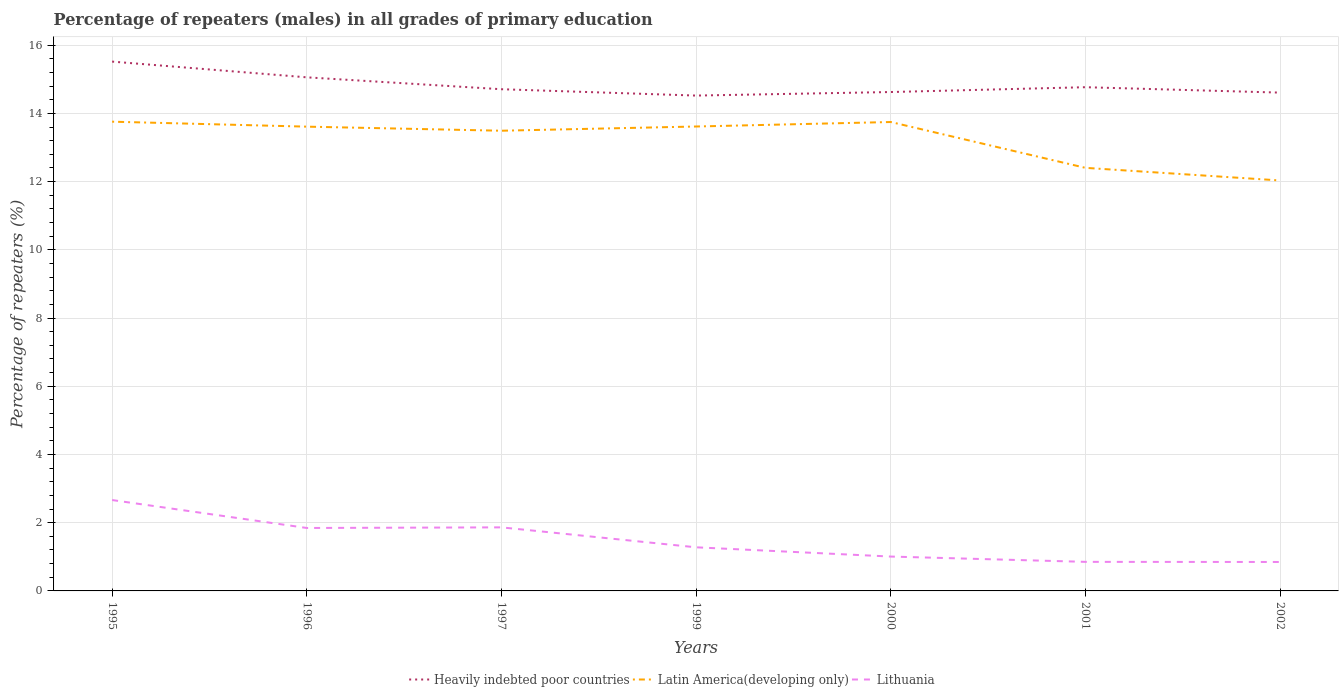How many different coloured lines are there?
Ensure brevity in your answer.  3. Across all years, what is the maximum percentage of repeaters (males) in Lithuania?
Provide a succinct answer. 0.85. In which year was the percentage of repeaters (males) in Latin America(developing only) maximum?
Make the answer very short. 2002. What is the total percentage of repeaters (males) in Latin America(developing only) in the graph?
Provide a short and direct response. 1.21. What is the difference between the highest and the second highest percentage of repeaters (males) in Lithuania?
Your response must be concise. 1.82. Is the percentage of repeaters (males) in Heavily indebted poor countries strictly greater than the percentage of repeaters (males) in Lithuania over the years?
Provide a succinct answer. No. How many years are there in the graph?
Your response must be concise. 7. What is the difference between two consecutive major ticks on the Y-axis?
Keep it short and to the point. 2. Are the values on the major ticks of Y-axis written in scientific E-notation?
Provide a short and direct response. No. Does the graph contain grids?
Offer a very short reply. Yes. How many legend labels are there?
Your response must be concise. 3. How are the legend labels stacked?
Provide a short and direct response. Horizontal. What is the title of the graph?
Offer a terse response. Percentage of repeaters (males) in all grades of primary education. Does "Sri Lanka" appear as one of the legend labels in the graph?
Your answer should be compact. No. What is the label or title of the Y-axis?
Make the answer very short. Percentage of repeaters (%). What is the Percentage of repeaters (%) of Heavily indebted poor countries in 1995?
Your answer should be very brief. 15.52. What is the Percentage of repeaters (%) of Latin America(developing only) in 1995?
Your answer should be compact. 13.76. What is the Percentage of repeaters (%) in Lithuania in 1995?
Ensure brevity in your answer.  2.66. What is the Percentage of repeaters (%) of Heavily indebted poor countries in 1996?
Offer a terse response. 15.06. What is the Percentage of repeaters (%) in Latin America(developing only) in 1996?
Keep it short and to the point. 13.61. What is the Percentage of repeaters (%) of Lithuania in 1996?
Your answer should be compact. 1.85. What is the Percentage of repeaters (%) of Heavily indebted poor countries in 1997?
Your answer should be compact. 14.71. What is the Percentage of repeaters (%) of Latin America(developing only) in 1997?
Offer a terse response. 13.49. What is the Percentage of repeaters (%) in Lithuania in 1997?
Keep it short and to the point. 1.86. What is the Percentage of repeaters (%) of Heavily indebted poor countries in 1999?
Provide a succinct answer. 14.52. What is the Percentage of repeaters (%) in Latin America(developing only) in 1999?
Offer a very short reply. 13.62. What is the Percentage of repeaters (%) in Lithuania in 1999?
Provide a short and direct response. 1.28. What is the Percentage of repeaters (%) in Heavily indebted poor countries in 2000?
Your response must be concise. 14.63. What is the Percentage of repeaters (%) in Latin America(developing only) in 2000?
Offer a terse response. 13.75. What is the Percentage of repeaters (%) of Lithuania in 2000?
Your response must be concise. 1.01. What is the Percentage of repeaters (%) of Heavily indebted poor countries in 2001?
Your answer should be compact. 14.77. What is the Percentage of repeaters (%) of Latin America(developing only) in 2001?
Ensure brevity in your answer.  12.4. What is the Percentage of repeaters (%) in Lithuania in 2001?
Provide a short and direct response. 0.85. What is the Percentage of repeaters (%) of Heavily indebted poor countries in 2002?
Offer a terse response. 14.61. What is the Percentage of repeaters (%) in Latin America(developing only) in 2002?
Provide a succinct answer. 12.03. What is the Percentage of repeaters (%) in Lithuania in 2002?
Provide a short and direct response. 0.85. Across all years, what is the maximum Percentage of repeaters (%) of Heavily indebted poor countries?
Offer a very short reply. 15.52. Across all years, what is the maximum Percentage of repeaters (%) of Latin America(developing only)?
Your answer should be compact. 13.76. Across all years, what is the maximum Percentage of repeaters (%) in Lithuania?
Your response must be concise. 2.66. Across all years, what is the minimum Percentage of repeaters (%) in Heavily indebted poor countries?
Give a very brief answer. 14.52. Across all years, what is the minimum Percentage of repeaters (%) in Latin America(developing only)?
Your answer should be compact. 12.03. Across all years, what is the minimum Percentage of repeaters (%) in Lithuania?
Make the answer very short. 0.85. What is the total Percentage of repeaters (%) in Heavily indebted poor countries in the graph?
Make the answer very short. 103.81. What is the total Percentage of repeaters (%) in Latin America(developing only) in the graph?
Make the answer very short. 92.66. What is the total Percentage of repeaters (%) in Lithuania in the graph?
Provide a succinct answer. 10.36. What is the difference between the Percentage of repeaters (%) in Heavily indebted poor countries in 1995 and that in 1996?
Provide a short and direct response. 0.46. What is the difference between the Percentage of repeaters (%) of Latin America(developing only) in 1995 and that in 1996?
Make the answer very short. 0.15. What is the difference between the Percentage of repeaters (%) in Lithuania in 1995 and that in 1996?
Make the answer very short. 0.82. What is the difference between the Percentage of repeaters (%) of Heavily indebted poor countries in 1995 and that in 1997?
Offer a very short reply. 0.81. What is the difference between the Percentage of repeaters (%) in Latin America(developing only) in 1995 and that in 1997?
Give a very brief answer. 0.27. What is the difference between the Percentage of repeaters (%) in Lithuania in 1995 and that in 1997?
Provide a short and direct response. 0.8. What is the difference between the Percentage of repeaters (%) of Latin America(developing only) in 1995 and that in 1999?
Make the answer very short. 0.14. What is the difference between the Percentage of repeaters (%) in Lithuania in 1995 and that in 1999?
Your response must be concise. 1.39. What is the difference between the Percentage of repeaters (%) of Heavily indebted poor countries in 1995 and that in 2000?
Provide a short and direct response. 0.89. What is the difference between the Percentage of repeaters (%) in Latin America(developing only) in 1995 and that in 2000?
Provide a succinct answer. 0.01. What is the difference between the Percentage of repeaters (%) of Lithuania in 1995 and that in 2000?
Your answer should be compact. 1.66. What is the difference between the Percentage of repeaters (%) in Heavily indebted poor countries in 1995 and that in 2001?
Provide a short and direct response. 0.75. What is the difference between the Percentage of repeaters (%) of Latin America(developing only) in 1995 and that in 2001?
Keep it short and to the point. 1.35. What is the difference between the Percentage of repeaters (%) in Lithuania in 1995 and that in 2001?
Offer a very short reply. 1.81. What is the difference between the Percentage of repeaters (%) in Heavily indebted poor countries in 1995 and that in 2002?
Offer a terse response. 0.91. What is the difference between the Percentage of repeaters (%) in Latin America(developing only) in 1995 and that in 2002?
Give a very brief answer. 1.72. What is the difference between the Percentage of repeaters (%) of Lithuania in 1995 and that in 2002?
Offer a terse response. 1.82. What is the difference between the Percentage of repeaters (%) in Heavily indebted poor countries in 1996 and that in 1997?
Your answer should be compact. 0.35. What is the difference between the Percentage of repeaters (%) in Latin America(developing only) in 1996 and that in 1997?
Ensure brevity in your answer.  0.12. What is the difference between the Percentage of repeaters (%) of Lithuania in 1996 and that in 1997?
Give a very brief answer. -0.02. What is the difference between the Percentage of repeaters (%) of Heavily indebted poor countries in 1996 and that in 1999?
Keep it short and to the point. 0.53. What is the difference between the Percentage of repeaters (%) of Latin America(developing only) in 1996 and that in 1999?
Offer a very short reply. -0. What is the difference between the Percentage of repeaters (%) in Lithuania in 1996 and that in 1999?
Offer a very short reply. 0.57. What is the difference between the Percentage of repeaters (%) of Heavily indebted poor countries in 1996 and that in 2000?
Ensure brevity in your answer.  0.43. What is the difference between the Percentage of repeaters (%) of Latin America(developing only) in 1996 and that in 2000?
Offer a terse response. -0.14. What is the difference between the Percentage of repeaters (%) of Lithuania in 1996 and that in 2000?
Keep it short and to the point. 0.84. What is the difference between the Percentage of repeaters (%) of Heavily indebted poor countries in 1996 and that in 2001?
Give a very brief answer. 0.29. What is the difference between the Percentage of repeaters (%) of Latin America(developing only) in 1996 and that in 2001?
Your response must be concise. 1.21. What is the difference between the Percentage of repeaters (%) of Lithuania in 1996 and that in 2001?
Your answer should be compact. 0.99. What is the difference between the Percentage of repeaters (%) in Heavily indebted poor countries in 1996 and that in 2002?
Your response must be concise. 0.45. What is the difference between the Percentage of repeaters (%) in Latin America(developing only) in 1996 and that in 2002?
Offer a very short reply. 1.58. What is the difference between the Percentage of repeaters (%) in Heavily indebted poor countries in 1997 and that in 1999?
Ensure brevity in your answer.  0.19. What is the difference between the Percentage of repeaters (%) in Latin America(developing only) in 1997 and that in 1999?
Your answer should be compact. -0.12. What is the difference between the Percentage of repeaters (%) of Lithuania in 1997 and that in 1999?
Your answer should be very brief. 0.58. What is the difference between the Percentage of repeaters (%) in Heavily indebted poor countries in 1997 and that in 2000?
Make the answer very short. 0.08. What is the difference between the Percentage of repeaters (%) in Latin America(developing only) in 1997 and that in 2000?
Make the answer very short. -0.26. What is the difference between the Percentage of repeaters (%) of Lithuania in 1997 and that in 2000?
Provide a succinct answer. 0.86. What is the difference between the Percentage of repeaters (%) of Heavily indebted poor countries in 1997 and that in 2001?
Give a very brief answer. -0.06. What is the difference between the Percentage of repeaters (%) in Latin America(developing only) in 1997 and that in 2001?
Your answer should be very brief. 1.09. What is the difference between the Percentage of repeaters (%) of Lithuania in 1997 and that in 2001?
Provide a short and direct response. 1.01. What is the difference between the Percentage of repeaters (%) in Heavily indebted poor countries in 1997 and that in 2002?
Your answer should be very brief. 0.1. What is the difference between the Percentage of repeaters (%) of Latin America(developing only) in 1997 and that in 2002?
Give a very brief answer. 1.46. What is the difference between the Percentage of repeaters (%) of Lithuania in 1997 and that in 2002?
Provide a short and direct response. 1.01. What is the difference between the Percentage of repeaters (%) of Heavily indebted poor countries in 1999 and that in 2000?
Make the answer very short. -0.1. What is the difference between the Percentage of repeaters (%) in Latin America(developing only) in 1999 and that in 2000?
Offer a terse response. -0.13. What is the difference between the Percentage of repeaters (%) in Lithuania in 1999 and that in 2000?
Offer a terse response. 0.27. What is the difference between the Percentage of repeaters (%) in Heavily indebted poor countries in 1999 and that in 2001?
Offer a very short reply. -0.25. What is the difference between the Percentage of repeaters (%) of Latin America(developing only) in 1999 and that in 2001?
Keep it short and to the point. 1.21. What is the difference between the Percentage of repeaters (%) of Lithuania in 1999 and that in 2001?
Keep it short and to the point. 0.43. What is the difference between the Percentage of repeaters (%) in Heavily indebted poor countries in 1999 and that in 2002?
Give a very brief answer. -0.09. What is the difference between the Percentage of repeaters (%) of Latin America(developing only) in 1999 and that in 2002?
Provide a succinct answer. 1.58. What is the difference between the Percentage of repeaters (%) of Lithuania in 1999 and that in 2002?
Make the answer very short. 0.43. What is the difference between the Percentage of repeaters (%) in Heavily indebted poor countries in 2000 and that in 2001?
Your response must be concise. -0.14. What is the difference between the Percentage of repeaters (%) of Latin America(developing only) in 2000 and that in 2001?
Keep it short and to the point. 1.34. What is the difference between the Percentage of repeaters (%) in Lithuania in 2000 and that in 2001?
Make the answer very short. 0.16. What is the difference between the Percentage of repeaters (%) in Heavily indebted poor countries in 2000 and that in 2002?
Your response must be concise. 0.02. What is the difference between the Percentage of repeaters (%) in Latin America(developing only) in 2000 and that in 2002?
Your answer should be compact. 1.71. What is the difference between the Percentage of repeaters (%) in Lithuania in 2000 and that in 2002?
Provide a succinct answer. 0.16. What is the difference between the Percentage of repeaters (%) of Heavily indebted poor countries in 2001 and that in 2002?
Your answer should be compact. 0.16. What is the difference between the Percentage of repeaters (%) of Latin America(developing only) in 2001 and that in 2002?
Make the answer very short. 0.37. What is the difference between the Percentage of repeaters (%) of Lithuania in 2001 and that in 2002?
Make the answer very short. 0. What is the difference between the Percentage of repeaters (%) of Heavily indebted poor countries in 1995 and the Percentage of repeaters (%) of Latin America(developing only) in 1996?
Offer a terse response. 1.91. What is the difference between the Percentage of repeaters (%) of Heavily indebted poor countries in 1995 and the Percentage of repeaters (%) of Lithuania in 1996?
Give a very brief answer. 13.67. What is the difference between the Percentage of repeaters (%) in Latin America(developing only) in 1995 and the Percentage of repeaters (%) in Lithuania in 1996?
Provide a succinct answer. 11.91. What is the difference between the Percentage of repeaters (%) in Heavily indebted poor countries in 1995 and the Percentage of repeaters (%) in Latin America(developing only) in 1997?
Your answer should be very brief. 2.03. What is the difference between the Percentage of repeaters (%) in Heavily indebted poor countries in 1995 and the Percentage of repeaters (%) in Lithuania in 1997?
Ensure brevity in your answer.  13.66. What is the difference between the Percentage of repeaters (%) of Latin America(developing only) in 1995 and the Percentage of repeaters (%) of Lithuania in 1997?
Provide a succinct answer. 11.89. What is the difference between the Percentage of repeaters (%) of Heavily indebted poor countries in 1995 and the Percentage of repeaters (%) of Latin America(developing only) in 1999?
Offer a terse response. 1.9. What is the difference between the Percentage of repeaters (%) in Heavily indebted poor countries in 1995 and the Percentage of repeaters (%) in Lithuania in 1999?
Your answer should be compact. 14.24. What is the difference between the Percentage of repeaters (%) in Latin America(developing only) in 1995 and the Percentage of repeaters (%) in Lithuania in 1999?
Give a very brief answer. 12.48. What is the difference between the Percentage of repeaters (%) of Heavily indebted poor countries in 1995 and the Percentage of repeaters (%) of Latin America(developing only) in 2000?
Make the answer very short. 1.77. What is the difference between the Percentage of repeaters (%) in Heavily indebted poor countries in 1995 and the Percentage of repeaters (%) in Lithuania in 2000?
Your answer should be very brief. 14.51. What is the difference between the Percentage of repeaters (%) in Latin America(developing only) in 1995 and the Percentage of repeaters (%) in Lithuania in 2000?
Keep it short and to the point. 12.75. What is the difference between the Percentage of repeaters (%) in Heavily indebted poor countries in 1995 and the Percentage of repeaters (%) in Latin America(developing only) in 2001?
Offer a terse response. 3.12. What is the difference between the Percentage of repeaters (%) in Heavily indebted poor countries in 1995 and the Percentage of repeaters (%) in Lithuania in 2001?
Give a very brief answer. 14.67. What is the difference between the Percentage of repeaters (%) in Latin America(developing only) in 1995 and the Percentage of repeaters (%) in Lithuania in 2001?
Provide a short and direct response. 12.9. What is the difference between the Percentage of repeaters (%) in Heavily indebted poor countries in 1995 and the Percentage of repeaters (%) in Latin America(developing only) in 2002?
Provide a short and direct response. 3.49. What is the difference between the Percentage of repeaters (%) of Heavily indebted poor countries in 1995 and the Percentage of repeaters (%) of Lithuania in 2002?
Your answer should be very brief. 14.67. What is the difference between the Percentage of repeaters (%) of Latin America(developing only) in 1995 and the Percentage of repeaters (%) of Lithuania in 2002?
Ensure brevity in your answer.  12.91. What is the difference between the Percentage of repeaters (%) in Heavily indebted poor countries in 1996 and the Percentage of repeaters (%) in Latin America(developing only) in 1997?
Offer a terse response. 1.57. What is the difference between the Percentage of repeaters (%) of Heavily indebted poor countries in 1996 and the Percentage of repeaters (%) of Lithuania in 1997?
Keep it short and to the point. 13.19. What is the difference between the Percentage of repeaters (%) in Latin America(developing only) in 1996 and the Percentage of repeaters (%) in Lithuania in 1997?
Keep it short and to the point. 11.75. What is the difference between the Percentage of repeaters (%) of Heavily indebted poor countries in 1996 and the Percentage of repeaters (%) of Latin America(developing only) in 1999?
Provide a succinct answer. 1.44. What is the difference between the Percentage of repeaters (%) in Heavily indebted poor countries in 1996 and the Percentage of repeaters (%) in Lithuania in 1999?
Make the answer very short. 13.78. What is the difference between the Percentage of repeaters (%) of Latin America(developing only) in 1996 and the Percentage of repeaters (%) of Lithuania in 1999?
Your answer should be compact. 12.33. What is the difference between the Percentage of repeaters (%) of Heavily indebted poor countries in 1996 and the Percentage of repeaters (%) of Latin America(developing only) in 2000?
Offer a very short reply. 1.31. What is the difference between the Percentage of repeaters (%) of Heavily indebted poor countries in 1996 and the Percentage of repeaters (%) of Lithuania in 2000?
Your answer should be compact. 14.05. What is the difference between the Percentage of repeaters (%) of Latin America(developing only) in 1996 and the Percentage of repeaters (%) of Lithuania in 2000?
Your response must be concise. 12.6. What is the difference between the Percentage of repeaters (%) of Heavily indebted poor countries in 1996 and the Percentage of repeaters (%) of Latin America(developing only) in 2001?
Ensure brevity in your answer.  2.65. What is the difference between the Percentage of repeaters (%) in Heavily indebted poor countries in 1996 and the Percentage of repeaters (%) in Lithuania in 2001?
Your response must be concise. 14.21. What is the difference between the Percentage of repeaters (%) of Latin America(developing only) in 1996 and the Percentage of repeaters (%) of Lithuania in 2001?
Make the answer very short. 12.76. What is the difference between the Percentage of repeaters (%) of Heavily indebted poor countries in 1996 and the Percentage of repeaters (%) of Latin America(developing only) in 2002?
Ensure brevity in your answer.  3.02. What is the difference between the Percentage of repeaters (%) of Heavily indebted poor countries in 1996 and the Percentage of repeaters (%) of Lithuania in 2002?
Ensure brevity in your answer.  14.21. What is the difference between the Percentage of repeaters (%) of Latin America(developing only) in 1996 and the Percentage of repeaters (%) of Lithuania in 2002?
Your answer should be compact. 12.76. What is the difference between the Percentage of repeaters (%) of Heavily indebted poor countries in 1997 and the Percentage of repeaters (%) of Latin America(developing only) in 1999?
Provide a succinct answer. 1.09. What is the difference between the Percentage of repeaters (%) in Heavily indebted poor countries in 1997 and the Percentage of repeaters (%) in Lithuania in 1999?
Your response must be concise. 13.43. What is the difference between the Percentage of repeaters (%) in Latin America(developing only) in 1997 and the Percentage of repeaters (%) in Lithuania in 1999?
Provide a short and direct response. 12.21. What is the difference between the Percentage of repeaters (%) in Heavily indebted poor countries in 1997 and the Percentage of repeaters (%) in Latin America(developing only) in 2000?
Your response must be concise. 0.96. What is the difference between the Percentage of repeaters (%) in Heavily indebted poor countries in 1997 and the Percentage of repeaters (%) in Lithuania in 2000?
Offer a very short reply. 13.7. What is the difference between the Percentage of repeaters (%) of Latin America(developing only) in 1997 and the Percentage of repeaters (%) of Lithuania in 2000?
Provide a succinct answer. 12.48. What is the difference between the Percentage of repeaters (%) in Heavily indebted poor countries in 1997 and the Percentage of repeaters (%) in Latin America(developing only) in 2001?
Your answer should be compact. 2.31. What is the difference between the Percentage of repeaters (%) in Heavily indebted poor countries in 1997 and the Percentage of repeaters (%) in Lithuania in 2001?
Offer a very short reply. 13.86. What is the difference between the Percentage of repeaters (%) of Latin America(developing only) in 1997 and the Percentage of repeaters (%) of Lithuania in 2001?
Provide a succinct answer. 12.64. What is the difference between the Percentage of repeaters (%) in Heavily indebted poor countries in 1997 and the Percentage of repeaters (%) in Latin America(developing only) in 2002?
Ensure brevity in your answer.  2.68. What is the difference between the Percentage of repeaters (%) in Heavily indebted poor countries in 1997 and the Percentage of repeaters (%) in Lithuania in 2002?
Offer a very short reply. 13.86. What is the difference between the Percentage of repeaters (%) in Latin America(developing only) in 1997 and the Percentage of repeaters (%) in Lithuania in 2002?
Provide a succinct answer. 12.64. What is the difference between the Percentage of repeaters (%) in Heavily indebted poor countries in 1999 and the Percentage of repeaters (%) in Latin America(developing only) in 2000?
Provide a succinct answer. 0.78. What is the difference between the Percentage of repeaters (%) of Heavily indebted poor countries in 1999 and the Percentage of repeaters (%) of Lithuania in 2000?
Ensure brevity in your answer.  13.51. What is the difference between the Percentage of repeaters (%) of Latin America(developing only) in 1999 and the Percentage of repeaters (%) of Lithuania in 2000?
Your response must be concise. 12.61. What is the difference between the Percentage of repeaters (%) in Heavily indebted poor countries in 1999 and the Percentage of repeaters (%) in Latin America(developing only) in 2001?
Provide a short and direct response. 2.12. What is the difference between the Percentage of repeaters (%) in Heavily indebted poor countries in 1999 and the Percentage of repeaters (%) in Lithuania in 2001?
Offer a terse response. 13.67. What is the difference between the Percentage of repeaters (%) of Latin America(developing only) in 1999 and the Percentage of repeaters (%) of Lithuania in 2001?
Provide a succinct answer. 12.76. What is the difference between the Percentage of repeaters (%) of Heavily indebted poor countries in 1999 and the Percentage of repeaters (%) of Latin America(developing only) in 2002?
Provide a succinct answer. 2.49. What is the difference between the Percentage of repeaters (%) of Heavily indebted poor countries in 1999 and the Percentage of repeaters (%) of Lithuania in 2002?
Provide a succinct answer. 13.67. What is the difference between the Percentage of repeaters (%) in Latin America(developing only) in 1999 and the Percentage of repeaters (%) in Lithuania in 2002?
Your answer should be very brief. 12.77. What is the difference between the Percentage of repeaters (%) of Heavily indebted poor countries in 2000 and the Percentage of repeaters (%) of Latin America(developing only) in 2001?
Offer a very short reply. 2.22. What is the difference between the Percentage of repeaters (%) in Heavily indebted poor countries in 2000 and the Percentage of repeaters (%) in Lithuania in 2001?
Your response must be concise. 13.77. What is the difference between the Percentage of repeaters (%) in Latin America(developing only) in 2000 and the Percentage of repeaters (%) in Lithuania in 2001?
Give a very brief answer. 12.89. What is the difference between the Percentage of repeaters (%) of Heavily indebted poor countries in 2000 and the Percentage of repeaters (%) of Latin America(developing only) in 2002?
Provide a short and direct response. 2.59. What is the difference between the Percentage of repeaters (%) of Heavily indebted poor countries in 2000 and the Percentage of repeaters (%) of Lithuania in 2002?
Provide a succinct answer. 13.78. What is the difference between the Percentage of repeaters (%) in Latin America(developing only) in 2000 and the Percentage of repeaters (%) in Lithuania in 2002?
Your answer should be very brief. 12.9. What is the difference between the Percentage of repeaters (%) of Heavily indebted poor countries in 2001 and the Percentage of repeaters (%) of Latin America(developing only) in 2002?
Provide a short and direct response. 2.73. What is the difference between the Percentage of repeaters (%) in Heavily indebted poor countries in 2001 and the Percentage of repeaters (%) in Lithuania in 2002?
Your answer should be very brief. 13.92. What is the difference between the Percentage of repeaters (%) in Latin America(developing only) in 2001 and the Percentage of repeaters (%) in Lithuania in 2002?
Ensure brevity in your answer.  11.55. What is the average Percentage of repeaters (%) in Heavily indebted poor countries per year?
Your answer should be compact. 14.83. What is the average Percentage of repeaters (%) of Latin America(developing only) per year?
Make the answer very short. 13.24. What is the average Percentage of repeaters (%) in Lithuania per year?
Make the answer very short. 1.48. In the year 1995, what is the difference between the Percentage of repeaters (%) in Heavily indebted poor countries and Percentage of repeaters (%) in Latin America(developing only)?
Offer a very short reply. 1.76. In the year 1995, what is the difference between the Percentage of repeaters (%) in Heavily indebted poor countries and Percentage of repeaters (%) in Lithuania?
Provide a succinct answer. 12.85. In the year 1995, what is the difference between the Percentage of repeaters (%) in Latin America(developing only) and Percentage of repeaters (%) in Lithuania?
Your answer should be compact. 11.09. In the year 1996, what is the difference between the Percentage of repeaters (%) of Heavily indebted poor countries and Percentage of repeaters (%) of Latin America(developing only)?
Offer a very short reply. 1.45. In the year 1996, what is the difference between the Percentage of repeaters (%) in Heavily indebted poor countries and Percentage of repeaters (%) in Lithuania?
Provide a short and direct response. 13.21. In the year 1996, what is the difference between the Percentage of repeaters (%) of Latin America(developing only) and Percentage of repeaters (%) of Lithuania?
Offer a very short reply. 11.77. In the year 1997, what is the difference between the Percentage of repeaters (%) in Heavily indebted poor countries and Percentage of repeaters (%) in Latin America(developing only)?
Your response must be concise. 1.22. In the year 1997, what is the difference between the Percentage of repeaters (%) of Heavily indebted poor countries and Percentage of repeaters (%) of Lithuania?
Offer a terse response. 12.85. In the year 1997, what is the difference between the Percentage of repeaters (%) of Latin America(developing only) and Percentage of repeaters (%) of Lithuania?
Ensure brevity in your answer.  11.63. In the year 1999, what is the difference between the Percentage of repeaters (%) of Heavily indebted poor countries and Percentage of repeaters (%) of Latin America(developing only)?
Offer a terse response. 0.91. In the year 1999, what is the difference between the Percentage of repeaters (%) of Heavily indebted poor countries and Percentage of repeaters (%) of Lithuania?
Ensure brevity in your answer.  13.24. In the year 1999, what is the difference between the Percentage of repeaters (%) of Latin America(developing only) and Percentage of repeaters (%) of Lithuania?
Give a very brief answer. 12.34. In the year 2000, what is the difference between the Percentage of repeaters (%) in Heavily indebted poor countries and Percentage of repeaters (%) in Latin America(developing only)?
Your response must be concise. 0.88. In the year 2000, what is the difference between the Percentage of repeaters (%) of Heavily indebted poor countries and Percentage of repeaters (%) of Lithuania?
Offer a very short reply. 13.62. In the year 2000, what is the difference between the Percentage of repeaters (%) of Latin America(developing only) and Percentage of repeaters (%) of Lithuania?
Your response must be concise. 12.74. In the year 2001, what is the difference between the Percentage of repeaters (%) in Heavily indebted poor countries and Percentage of repeaters (%) in Latin America(developing only)?
Offer a terse response. 2.36. In the year 2001, what is the difference between the Percentage of repeaters (%) in Heavily indebted poor countries and Percentage of repeaters (%) in Lithuania?
Make the answer very short. 13.92. In the year 2001, what is the difference between the Percentage of repeaters (%) of Latin America(developing only) and Percentage of repeaters (%) of Lithuania?
Provide a short and direct response. 11.55. In the year 2002, what is the difference between the Percentage of repeaters (%) in Heavily indebted poor countries and Percentage of repeaters (%) in Latin America(developing only)?
Provide a short and direct response. 2.58. In the year 2002, what is the difference between the Percentage of repeaters (%) of Heavily indebted poor countries and Percentage of repeaters (%) of Lithuania?
Give a very brief answer. 13.76. In the year 2002, what is the difference between the Percentage of repeaters (%) in Latin America(developing only) and Percentage of repeaters (%) in Lithuania?
Your answer should be very brief. 11.18. What is the ratio of the Percentage of repeaters (%) in Heavily indebted poor countries in 1995 to that in 1996?
Your answer should be compact. 1.03. What is the ratio of the Percentage of repeaters (%) of Latin America(developing only) in 1995 to that in 1996?
Provide a short and direct response. 1.01. What is the ratio of the Percentage of repeaters (%) in Lithuania in 1995 to that in 1996?
Your answer should be very brief. 1.44. What is the ratio of the Percentage of repeaters (%) of Heavily indebted poor countries in 1995 to that in 1997?
Ensure brevity in your answer.  1.06. What is the ratio of the Percentage of repeaters (%) of Latin America(developing only) in 1995 to that in 1997?
Your response must be concise. 1.02. What is the ratio of the Percentage of repeaters (%) of Lithuania in 1995 to that in 1997?
Keep it short and to the point. 1.43. What is the ratio of the Percentage of repeaters (%) in Heavily indebted poor countries in 1995 to that in 1999?
Your response must be concise. 1.07. What is the ratio of the Percentage of repeaters (%) of Latin America(developing only) in 1995 to that in 1999?
Your answer should be compact. 1.01. What is the ratio of the Percentage of repeaters (%) of Lithuania in 1995 to that in 1999?
Keep it short and to the point. 2.08. What is the ratio of the Percentage of repeaters (%) in Heavily indebted poor countries in 1995 to that in 2000?
Your response must be concise. 1.06. What is the ratio of the Percentage of repeaters (%) of Lithuania in 1995 to that in 2000?
Provide a short and direct response. 2.64. What is the ratio of the Percentage of repeaters (%) of Heavily indebted poor countries in 1995 to that in 2001?
Make the answer very short. 1.05. What is the ratio of the Percentage of repeaters (%) in Latin America(developing only) in 1995 to that in 2001?
Keep it short and to the point. 1.11. What is the ratio of the Percentage of repeaters (%) in Lithuania in 1995 to that in 2001?
Provide a succinct answer. 3.13. What is the ratio of the Percentage of repeaters (%) of Heavily indebted poor countries in 1995 to that in 2002?
Your answer should be compact. 1.06. What is the ratio of the Percentage of repeaters (%) of Latin America(developing only) in 1995 to that in 2002?
Keep it short and to the point. 1.14. What is the ratio of the Percentage of repeaters (%) in Lithuania in 1995 to that in 2002?
Make the answer very short. 3.14. What is the ratio of the Percentage of repeaters (%) of Heavily indebted poor countries in 1996 to that in 1997?
Keep it short and to the point. 1.02. What is the ratio of the Percentage of repeaters (%) in Latin America(developing only) in 1996 to that in 1997?
Give a very brief answer. 1.01. What is the ratio of the Percentage of repeaters (%) of Lithuania in 1996 to that in 1997?
Offer a very short reply. 0.99. What is the ratio of the Percentage of repeaters (%) in Heavily indebted poor countries in 1996 to that in 1999?
Ensure brevity in your answer.  1.04. What is the ratio of the Percentage of repeaters (%) in Latin America(developing only) in 1996 to that in 1999?
Provide a short and direct response. 1. What is the ratio of the Percentage of repeaters (%) of Lithuania in 1996 to that in 1999?
Your answer should be very brief. 1.44. What is the ratio of the Percentage of repeaters (%) in Heavily indebted poor countries in 1996 to that in 2000?
Your answer should be very brief. 1.03. What is the ratio of the Percentage of repeaters (%) in Lithuania in 1996 to that in 2000?
Make the answer very short. 1.83. What is the ratio of the Percentage of repeaters (%) of Heavily indebted poor countries in 1996 to that in 2001?
Provide a succinct answer. 1.02. What is the ratio of the Percentage of repeaters (%) of Latin America(developing only) in 1996 to that in 2001?
Offer a terse response. 1.1. What is the ratio of the Percentage of repeaters (%) in Lithuania in 1996 to that in 2001?
Make the answer very short. 2.17. What is the ratio of the Percentage of repeaters (%) of Heavily indebted poor countries in 1996 to that in 2002?
Give a very brief answer. 1.03. What is the ratio of the Percentage of repeaters (%) in Latin America(developing only) in 1996 to that in 2002?
Keep it short and to the point. 1.13. What is the ratio of the Percentage of repeaters (%) of Lithuania in 1996 to that in 2002?
Offer a very short reply. 2.17. What is the ratio of the Percentage of repeaters (%) of Heavily indebted poor countries in 1997 to that in 1999?
Offer a very short reply. 1.01. What is the ratio of the Percentage of repeaters (%) of Latin America(developing only) in 1997 to that in 1999?
Your answer should be very brief. 0.99. What is the ratio of the Percentage of repeaters (%) in Lithuania in 1997 to that in 1999?
Ensure brevity in your answer.  1.46. What is the ratio of the Percentage of repeaters (%) of Heavily indebted poor countries in 1997 to that in 2000?
Provide a short and direct response. 1.01. What is the ratio of the Percentage of repeaters (%) of Latin America(developing only) in 1997 to that in 2000?
Give a very brief answer. 0.98. What is the ratio of the Percentage of repeaters (%) in Lithuania in 1997 to that in 2000?
Provide a short and direct response. 1.85. What is the ratio of the Percentage of repeaters (%) in Latin America(developing only) in 1997 to that in 2001?
Your answer should be compact. 1.09. What is the ratio of the Percentage of repeaters (%) of Lithuania in 1997 to that in 2001?
Offer a terse response. 2.19. What is the ratio of the Percentage of repeaters (%) in Heavily indebted poor countries in 1997 to that in 2002?
Your response must be concise. 1.01. What is the ratio of the Percentage of repeaters (%) of Latin America(developing only) in 1997 to that in 2002?
Give a very brief answer. 1.12. What is the ratio of the Percentage of repeaters (%) of Lithuania in 1997 to that in 2002?
Your answer should be very brief. 2.2. What is the ratio of the Percentage of repeaters (%) of Heavily indebted poor countries in 1999 to that in 2000?
Give a very brief answer. 0.99. What is the ratio of the Percentage of repeaters (%) in Latin America(developing only) in 1999 to that in 2000?
Offer a very short reply. 0.99. What is the ratio of the Percentage of repeaters (%) in Lithuania in 1999 to that in 2000?
Keep it short and to the point. 1.27. What is the ratio of the Percentage of repeaters (%) in Heavily indebted poor countries in 1999 to that in 2001?
Offer a terse response. 0.98. What is the ratio of the Percentage of repeaters (%) of Latin America(developing only) in 1999 to that in 2001?
Keep it short and to the point. 1.1. What is the ratio of the Percentage of repeaters (%) of Lithuania in 1999 to that in 2001?
Your answer should be compact. 1.5. What is the ratio of the Percentage of repeaters (%) in Latin America(developing only) in 1999 to that in 2002?
Your answer should be very brief. 1.13. What is the ratio of the Percentage of repeaters (%) in Lithuania in 1999 to that in 2002?
Provide a succinct answer. 1.51. What is the ratio of the Percentage of repeaters (%) of Latin America(developing only) in 2000 to that in 2001?
Make the answer very short. 1.11. What is the ratio of the Percentage of repeaters (%) in Lithuania in 2000 to that in 2001?
Provide a succinct answer. 1.18. What is the ratio of the Percentage of repeaters (%) in Heavily indebted poor countries in 2000 to that in 2002?
Your answer should be very brief. 1. What is the ratio of the Percentage of repeaters (%) of Latin America(developing only) in 2000 to that in 2002?
Offer a terse response. 1.14. What is the ratio of the Percentage of repeaters (%) of Lithuania in 2000 to that in 2002?
Your answer should be very brief. 1.19. What is the ratio of the Percentage of repeaters (%) in Heavily indebted poor countries in 2001 to that in 2002?
Your answer should be compact. 1.01. What is the ratio of the Percentage of repeaters (%) in Latin America(developing only) in 2001 to that in 2002?
Ensure brevity in your answer.  1.03. What is the difference between the highest and the second highest Percentage of repeaters (%) of Heavily indebted poor countries?
Give a very brief answer. 0.46. What is the difference between the highest and the second highest Percentage of repeaters (%) of Latin America(developing only)?
Offer a terse response. 0.01. What is the difference between the highest and the second highest Percentage of repeaters (%) of Lithuania?
Your answer should be compact. 0.8. What is the difference between the highest and the lowest Percentage of repeaters (%) of Latin America(developing only)?
Ensure brevity in your answer.  1.72. What is the difference between the highest and the lowest Percentage of repeaters (%) of Lithuania?
Your answer should be compact. 1.82. 